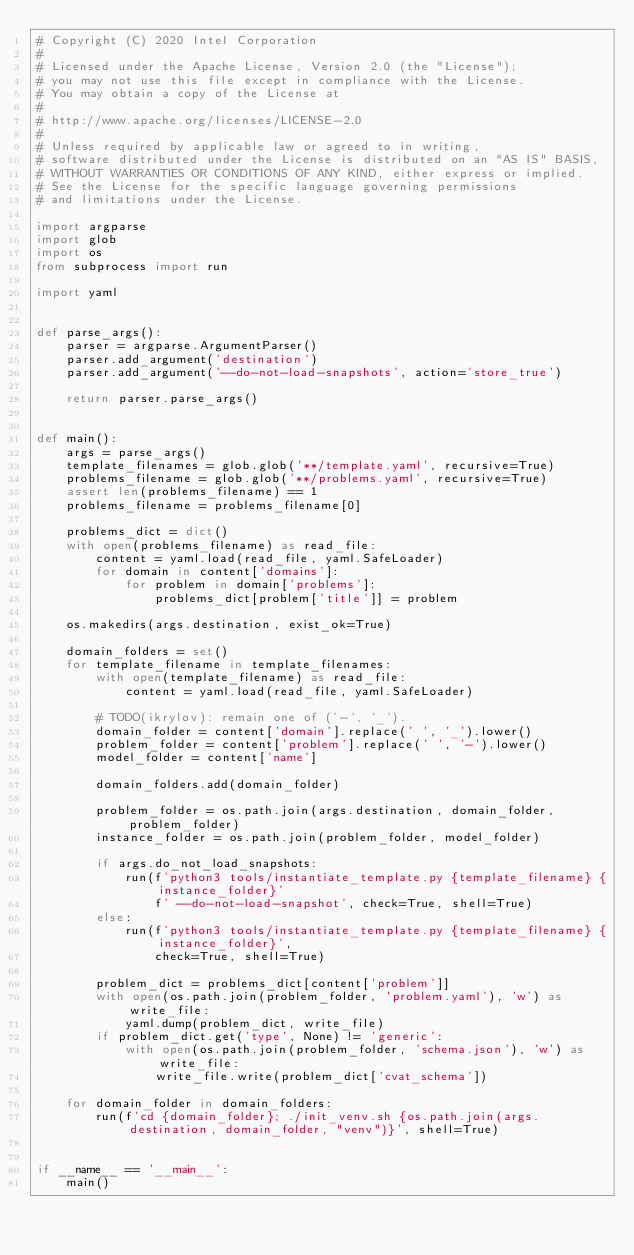Convert code to text. <code><loc_0><loc_0><loc_500><loc_500><_Python_># Copyright (C) 2020 Intel Corporation
#
# Licensed under the Apache License, Version 2.0 (the "License");
# you may not use this file except in compliance with the License.
# You may obtain a copy of the License at
#
# http://www.apache.org/licenses/LICENSE-2.0
#
# Unless required by applicable law or agreed to in writing,
# software distributed under the License is distributed on an "AS IS" BASIS,
# WITHOUT WARRANTIES OR CONDITIONS OF ANY KIND, either express or implied.
# See the License for the specific language governing permissions
# and limitations under the License.

import argparse
import glob
import os
from subprocess import run

import yaml


def parse_args():
    parser = argparse.ArgumentParser()
    parser.add_argument('destination')
    parser.add_argument('--do-not-load-snapshots', action='store_true')

    return parser.parse_args()


def main():
    args = parse_args()
    template_filenames = glob.glob('**/template.yaml', recursive=True)
    problems_filename = glob.glob('**/problems.yaml', recursive=True)
    assert len(problems_filename) == 1
    problems_filename = problems_filename[0]

    problems_dict = dict()
    with open(problems_filename) as read_file:
        content = yaml.load(read_file, yaml.SafeLoader)
        for domain in content['domains']:
            for problem in domain['problems']:
                problems_dict[problem['title']] = problem

    os.makedirs(args.destination, exist_ok=True)

    domain_folders = set()
    for template_filename in template_filenames:
        with open(template_filename) as read_file:
            content = yaml.load(read_file, yaml.SafeLoader)

        # TODO(ikrylov): remain one of ('-', '_').
        domain_folder = content['domain'].replace(' ', '_').lower()
        problem_folder = content['problem'].replace(' ', '-').lower()
        model_folder = content['name']

        domain_folders.add(domain_folder)

        problem_folder = os.path.join(args.destination, domain_folder, problem_folder)
        instance_folder = os.path.join(problem_folder, model_folder)

        if args.do_not_load_snapshots:
            run(f'python3 tools/instantiate_template.py {template_filename} {instance_folder}'
                f' --do-not-load-snapshot', check=True, shell=True)
        else:
            run(f'python3 tools/instantiate_template.py {template_filename} {instance_folder}',
                check=True, shell=True)

        problem_dict = problems_dict[content['problem']]
        with open(os.path.join(problem_folder, 'problem.yaml'), 'w') as write_file:
            yaml.dump(problem_dict, write_file)
        if problem_dict.get('type', None) != 'generic':
            with open(os.path.join(problem_folder, 'schema.json'), 'w') as write_file:
                write_file.write(problem_dict['cvat_schema'])

    for domain_folder in domain_folders:
        run(f'cd {domain_folder}; ./init_venv.sh {os.path.join(args.destination, domain_folder, "venv")}', shell=True)


if __name__ == '__main__':
    main()
</code> 